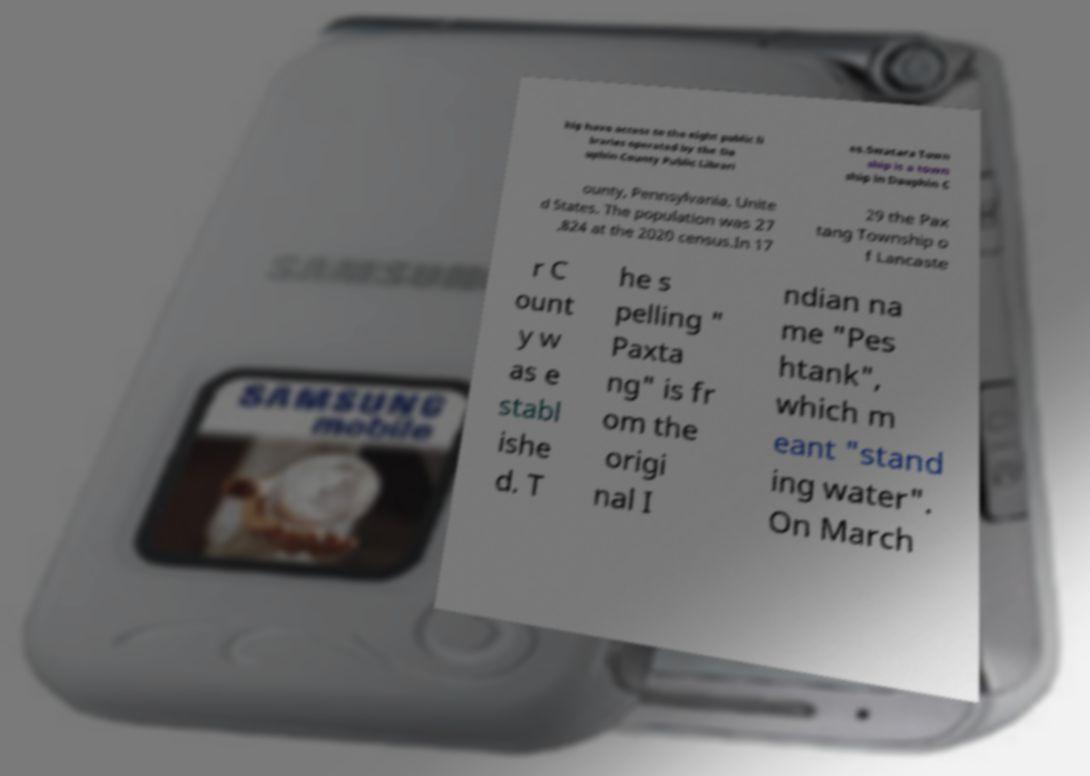Could you assist in decoding the text presented in this image and type it out clearly? hip have access to the eight public li braries operated by the Da uphin County Public Librari es.Swatara Town ship is a town ship in Dauphin C ounty, Pennsylvania, Unite d States. The population was 27 ,824 at the 2020 census.In 17 29 the Pax tang Township o f Lancaste r C ount y w as e stabl ishe d. T he s pelling " Paxta ng" is fr om the origi nal I ndian na me "Pes htank", which m eant "stand ing water". On March 